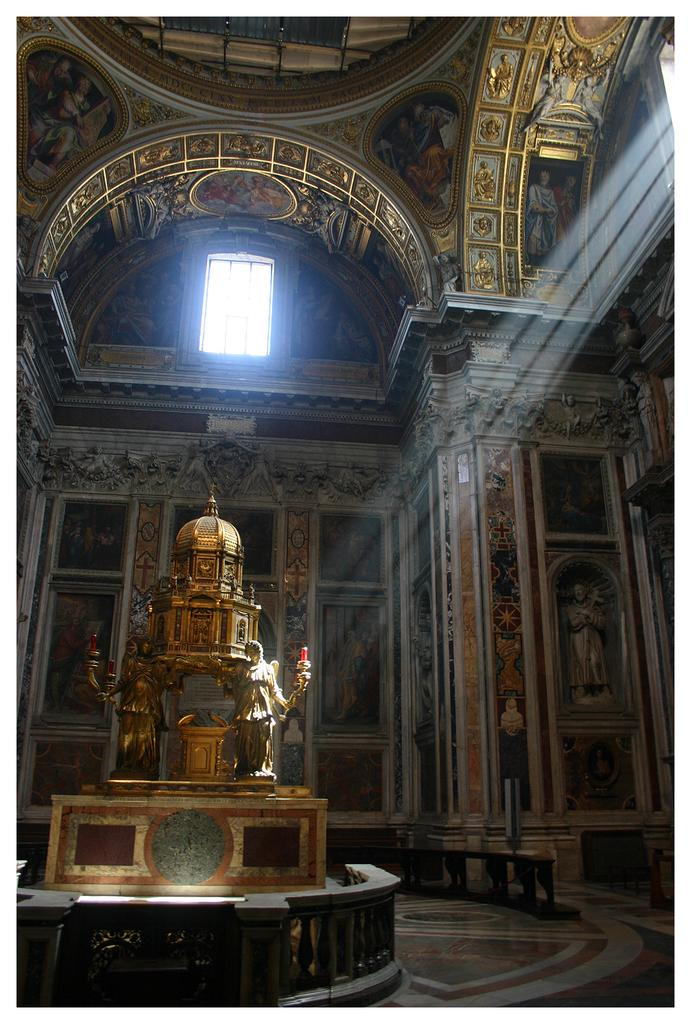What is the main structure in the image? There is a monument in the image. What is placed on the rock near the monument? There is a statue placed on a rock. Where are the windows located on the wall in the image? There are windows on the top right and center of the wall. What type of throat-soothing remedy can be seen in the image? There is no throat-soothing remedy present in the image. What type of disgusting substance can be seen on the statue in the image? There is no disgusting substance present on the statue in the image. 